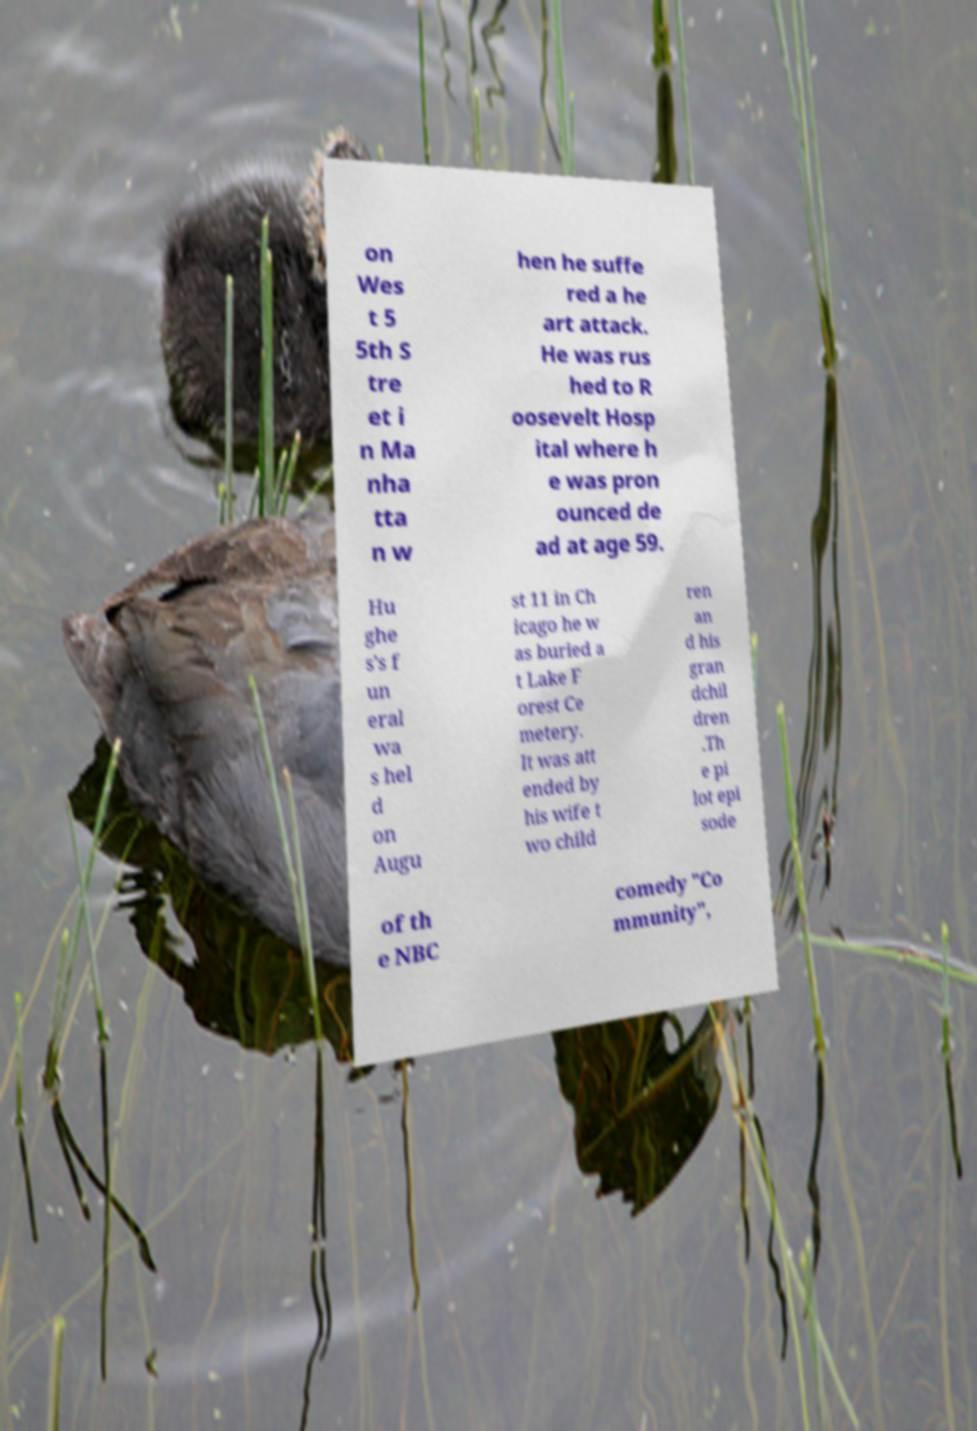Can you accurately transcribe the text from the provided image for me? on Wes t 5 5th S tre et i n Ma nha tta n w hen he suffe red a he art attack. He was rus hed to R oosevelt Hosp ital where h e was pron ounced de ad at age 59. Hu ghe s's f un eral wa s hel d on Augu st 11 in Ch icago he w as buried a t Lake F orest Ce metery. It was att ended by his wife t wo child ren an d his gran dchil dren .Th e pi lot epi sode of th e NBC comedy "Co mmunity", 